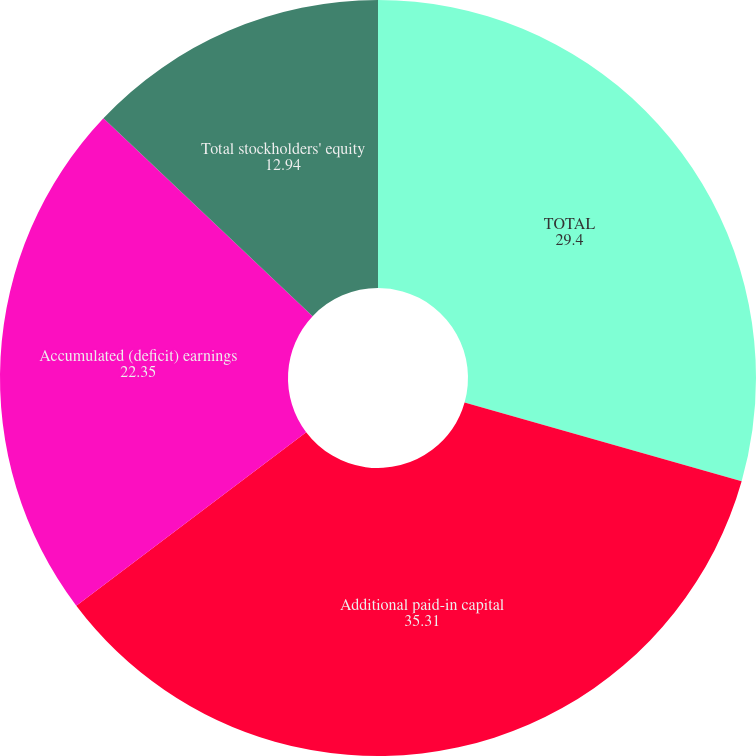<chart> <loc_0><loc_0><loc_500><loc_500><pie_chart><fcel>TOTAL<fcel>Additional paid-in capital<fcel>Accumulated (deficit) earnings<fcel>Total stockholders' equity<nl><fcel>29.4%<fcel>35.31%<fcel>22.35%<fcel>12.94%<nl></chart> 